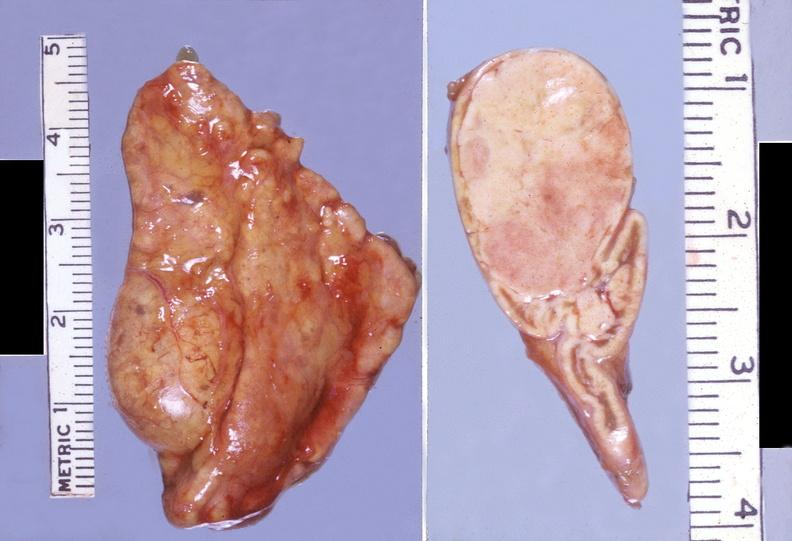does this image show adrenal, cortical adenoma non-functional?
Answer the question using a single word or phrase. Yes 